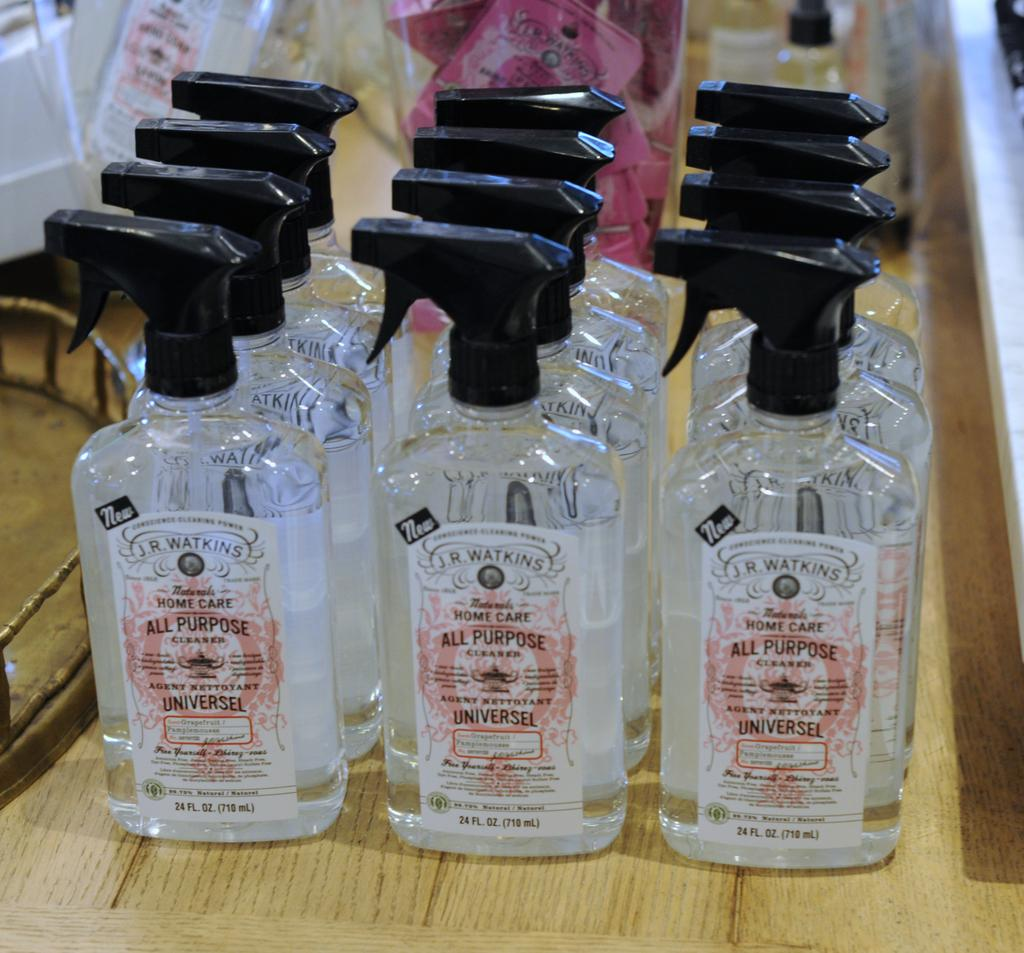Provide a one-sentence caption for the provided image. A group of twelve bottles of all purpose cleaner. 